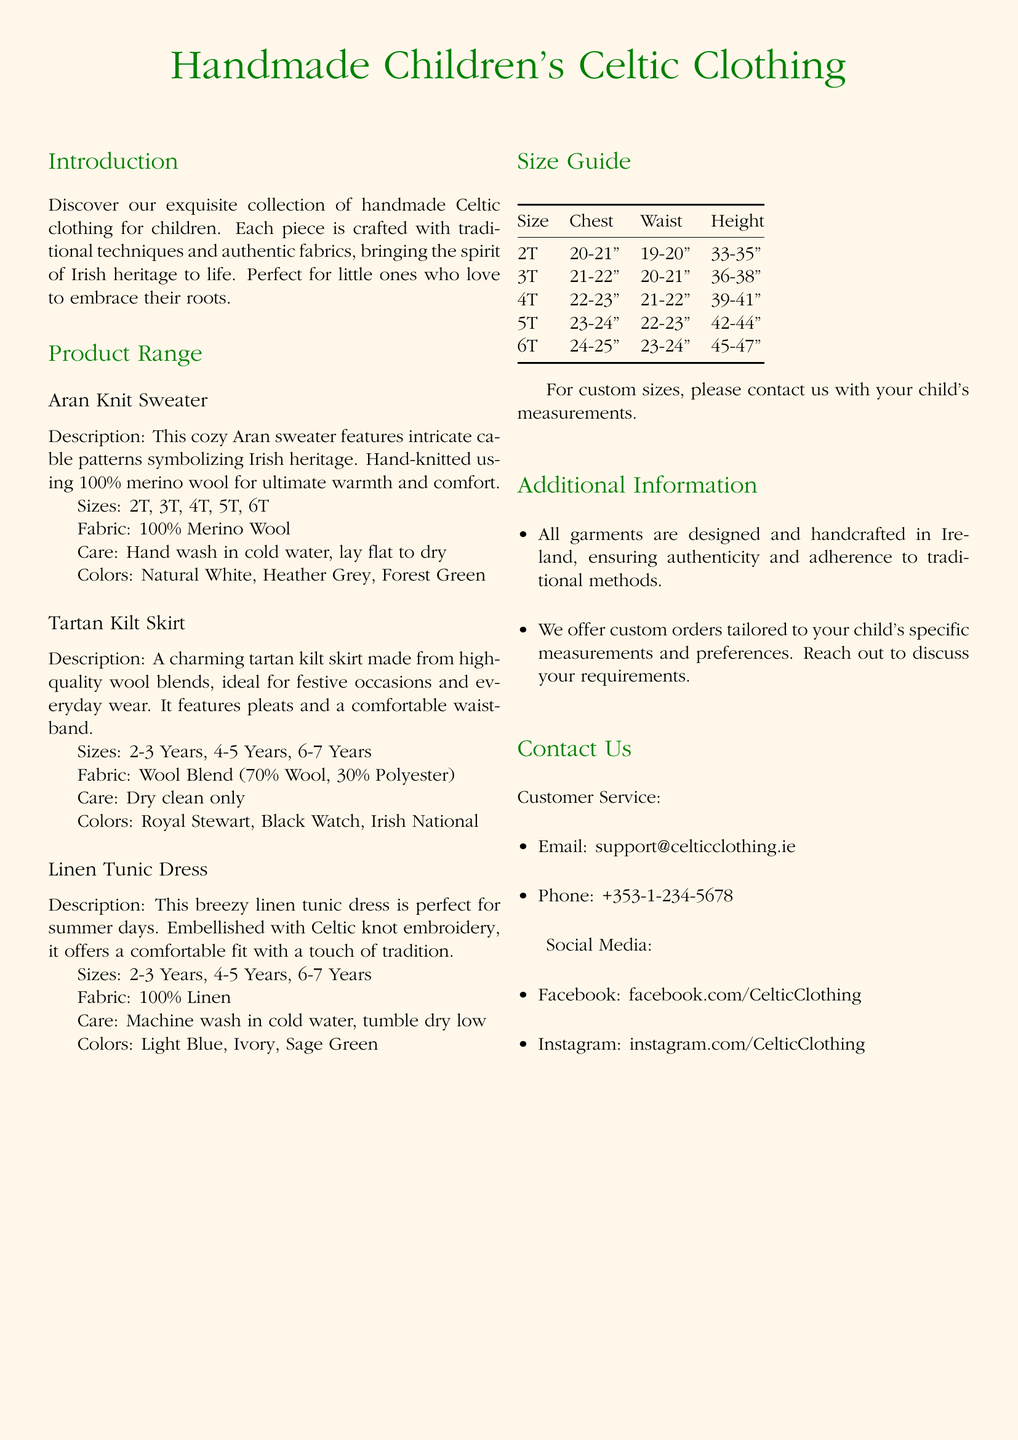What sizes are available for the Aran Knit Sweater? The sizes for the Aran Knit Sweater listed in the document are 2T, 3T, 4T, 5T, 6T.
Answer: 2T, 3T, 4T, 5T, 6T What fabric is used for the Linen Tunic Dress? The document specifies that the Linen Tunic Dress is made of 100% Linen.
Answer: 100% Linen What care instructions are provided for the Tartan Kilt Skirt? According to the document, the care instructions for the Tartan Kilt Skirt are dry clean only.
Answer: Dry clean only What is the chest measurement for size 5T? The chest measurement for size 5T is indicated in the size guide as 23-24 inches.
Answer: 23-24" How many years is the Tartan Kilt Skirt designed for? The document states that the Tartan Kilt Skirt is designed for ages 2-7 years.
Answer: 2-7 Years What is the description of the Aran Knit Sweater? The description in the document mentions that the Aran Knit Sweater features intricate cable patterns symbolizing Irish heritage and is hand-knitted using 100% merino wool.
Answer: Cozy Aran sweater with intricate cable patterns How can customers customize their orders? The document mentions that customers can contact the company with their child's measurements for custom sizes.
Answer: Contact with measurements Who is the target audience for this clothing line? The target audience specifically mentioned in the document is children who love to embrace their Irish roots.
Answer: Children What type of clothing item is embellished with Celtic knot embroidery? The document specifies that the Linen Tunic Dress is embellished with Celtic knot embroidery.
Answer: Linen Tunic Dress 